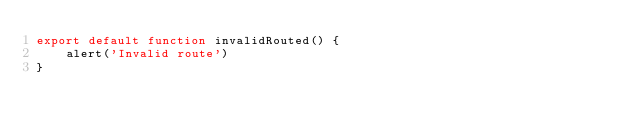<code> <loc_0><loc_0><loc_500><loc_500><_JavaScript_>export default function invalidRouted() {
    alert('Invalid route')
}
</code> 